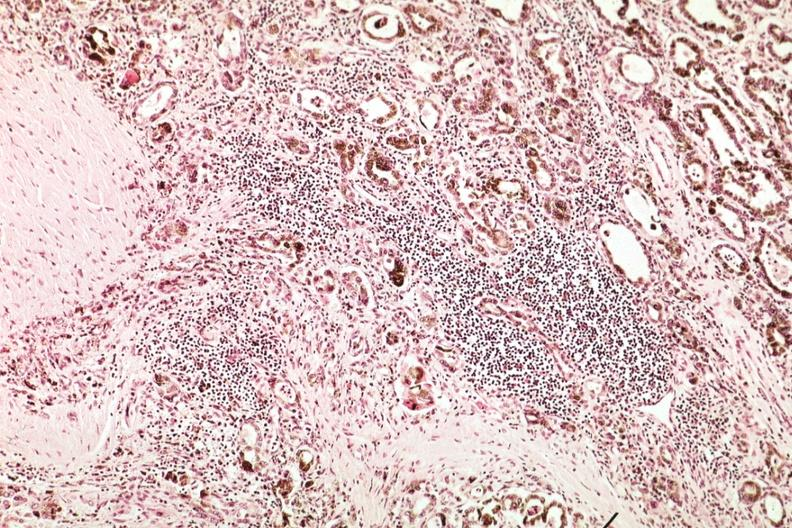what is present?
Answer the question using a single word or phrase. Hemochromatosis 